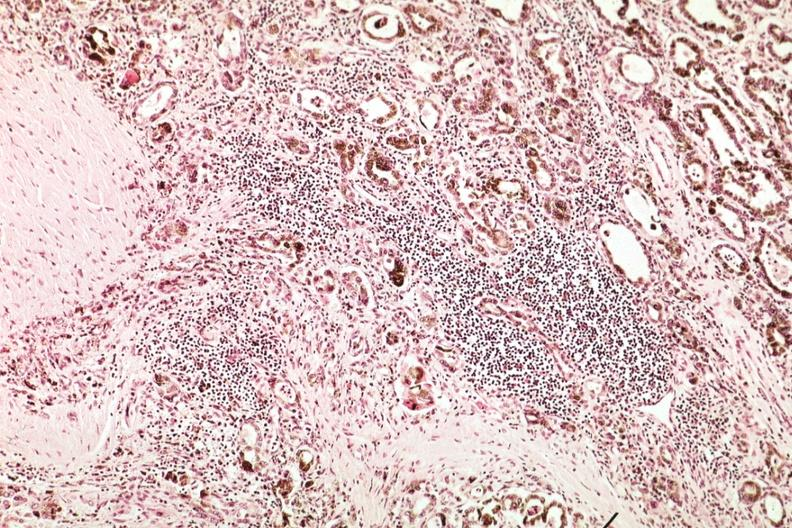what is present?
Answer the question using a single word or phrase. Hemochromatosis 